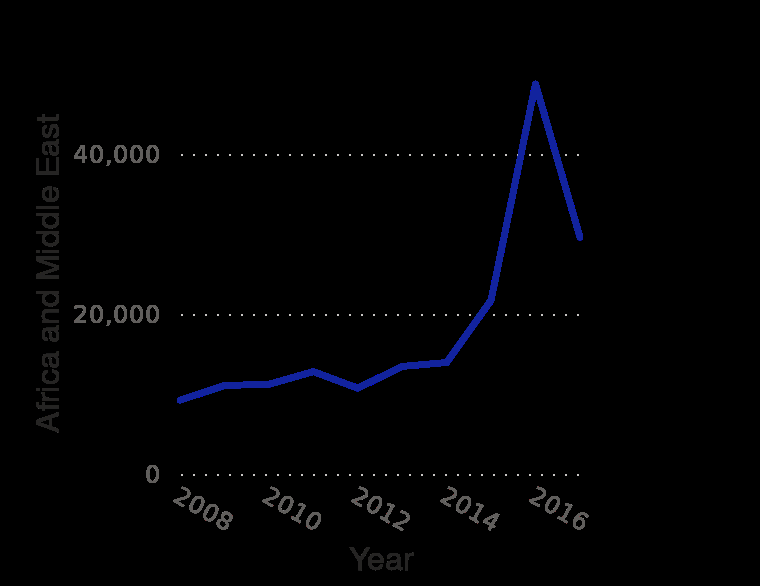<image>
please describe the details of the chart Number of permanent resident refugees admitted in Canada from 2008 to 2017 , by origin area is a line graph. The x-axis plots Year. There is a linear scale of range 0 to 40,000 along the y-axis, labeled Africa and Middle East. What is the general pattern in the number of refugees being admitted into Canada after 2016? The general pattern indicates a decline in the admittance of refugees into Canada after 2016. 